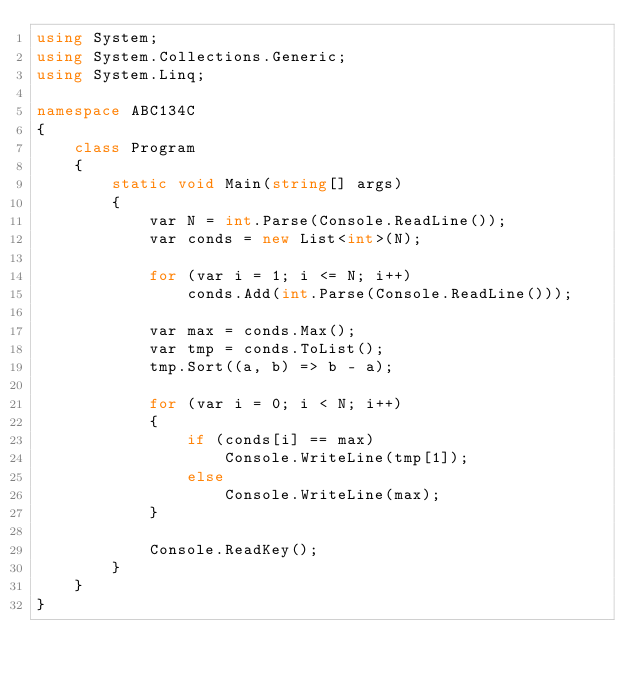Convert code to text. <code><loc_0><loc_0><loc_500><loc_500><_C#_>using System;
using System.Collections.Generic;
using System.Linq;

namespace ABC134C
{
    class Program
    {
        static void Main(string[] args)
        {
            var N = int.Parse(Console.ReadLine());
            var conds = new List<int>(N);

            for (var i = 1; i <= N; i++)
                conds.Add(int.Parse(Console.ReadLine()));

            var max = conds.Max();
            var tmp = conds.ToList();
            tmp.Sort((a, b) => b - a);

            for (var i = 0; i < N; i++)
            {
                if (conds[i] == max)
                    Console.WriteLine(tmp[1]);
                else
                    Console.WriteLine(max);
            }

            Console.ReadKey();
        }
    }
}</code> 